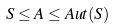<formula> <loc_0><loc_0><loc_500><loc_500>S \leq A \leq A u t ( S )</formula> 